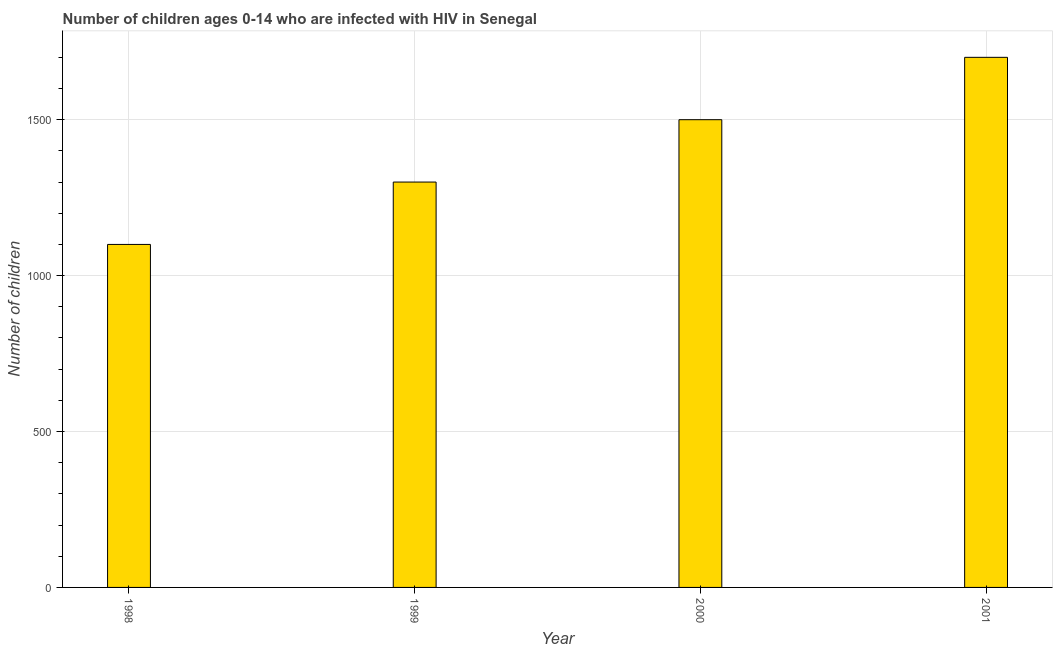Does the graph contain grids?
Ensure brevity in your answer.  Yes. What is the title of the graph?
Give a very brief answer. Number of children ages 0-14 who are infected with HIV in Senegal. What is the label or title of the Y-axis?
Ensure brevity in your answer.  Number of children. What is the number of children living with hiv in 1999?
Keep it short and to the point. 1300. Across all years, what is the maximum number of children living with hiv?
Give a very brief answer. 1700. Across all years, what is the minimum number of children living with hiv?
Make the answer very short. 1100. In which year was the number of children living with hiv maximum?
Your answer should be very brief. 2001. What is the sum of the number of children living with hiv?
Offer a terse response. 5600. What is the difference between the number of children living with hiv in 1999 and 2001?
Your response must be concise. -400. What is the average number of children living with hiv per year?
Provide a short and direct response. 1400. What is the median number of children living with hiv?
Provide a succinct answer. 1400. In how many years, is the number of children living with hiv greater than 600 ?
Make the answer very short. 4. What is the ratio of the number of children living with hiv in 2000 to that in 2001?
Your answer should be compact. 0.88. Is the difference between the number of children living with hiv in 1998 and 1999 greater than the difference between any two years?
Offer a very short reply. No. What is the difference between the highest and the lowest number of children living with hiv?
Your response must be concise. 600. In how many years, is the number of children living with hiv greater than the average number of children living with hiv taken over all years?
Offer a very short reply. 2. Are all the bars in the graph horizontal?
Your answer should be compact. No. What is the Number of children in 1998?
Your response must be concise. 1100. What is the Number of children of 1999?
Make the answer very short. 1300. What is the Number of children in 2000?
Your response must be concise. 1500. What is the Number of children in 2001?
Offer a very short reply. 1700. What is the difference between the Number of children in 1998 and 1999?
Your response must be concise. -200. What is the difference between the Number of children in 1998 and 2000?
Your answer should be very brief. -400. What is the difference between the Number of children in 1998 and 2001?
Offer a very short reply. -600. What is the difference between the Number of children in 1999 and 2000?
Offer a very short reply. -200. What is the difference between the Number of children in 1999 and 2001?
Keep it short and to the point. -400. What is the difference between the Number of children in 2000 and 2001?
Keep it short and to the point. -200. What is the ratio of the Number of children in 1998 to that in 1999?
Offer a terse response. 0.85. What is the ratio of the Number of children in 1998 to that in 2000?
Keep it short and to the point. 0.73. What is the ratio of the Number of children in 1998 to that in 2001?
Keep it short and to the point. 0.65. What is the ratio of the Number of children in 1999 to that in 2000?
Give a very brief answer. 0.87. What is the ratio of the Number of children in 1999 to that in 2001?
Ensure brevity in your answer.  0.77. What is the ratio of the Number of children in 2000 to that in 2001?
Ensure brevity in your answer.  0.88. 